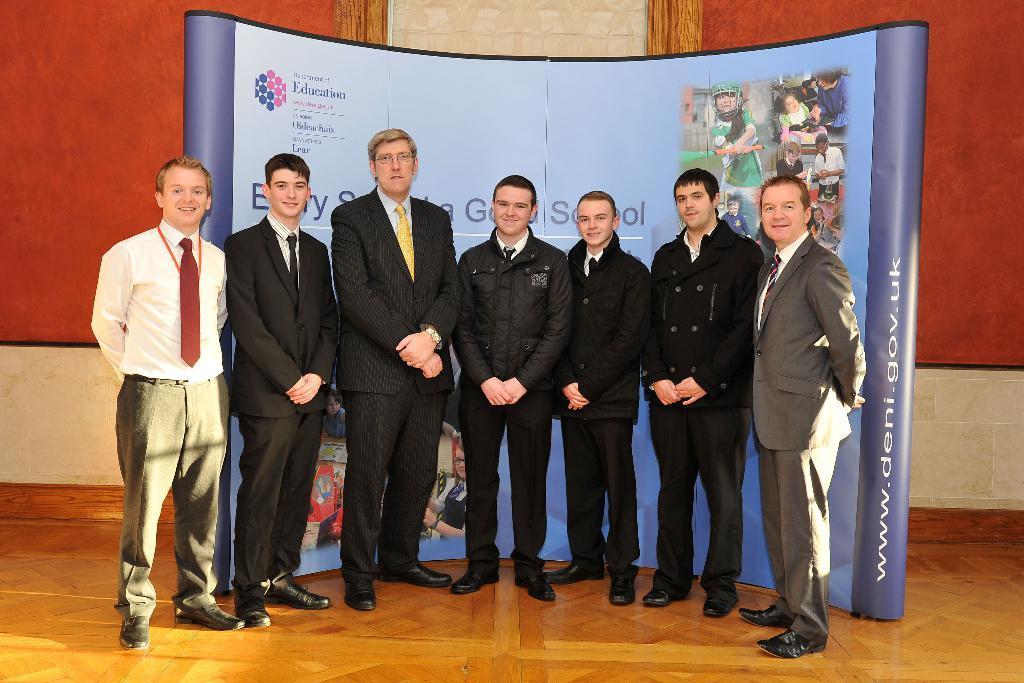Could you give a brief overview of what you see in this image? In this picture we can see a group of people standing on the path. There is a board and a wall in the background. 